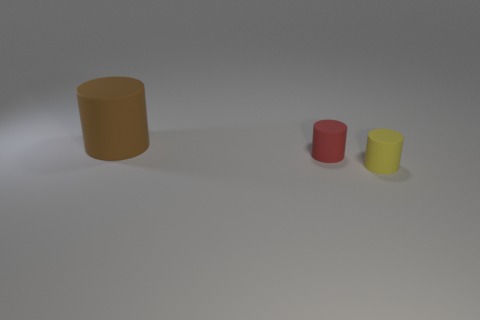Do the brown rubber cylinder and the yellow object have the same size?
Give a very brief answer. No. What number of balls are either tiny red matte things or large brown things?
Provide a succinct answer. 0. There is a tiny matte object behind the tiny cylinder that is to the right of the tiny red object; what color is it?
Keep it short and to the point. Red. Is the number of rubber objects that are in front of the yellow rubber thing less than the number of rubber objects on the left side of the red rubber cylinder?
Your answer should be compact. Yes. There is a brown thing; is it the same size as the red rubber cylinder that is on the left side of the yellow rubber cylinder?
Give a very brief answer. No. There is a rubber thing that is behind the tiny yellow cylinder and in front of the big object; what is its shape?
Your answer should be compact. Cylinder. There is a red object that is made of the same material as the yellow cylinder; what is its size?
Your answer should be very brief. Small. How many tiny rubber objects are right of the rubber object behind the red object?
Your answer should be compact. 2. Are the cylinder on the right side of the tiny red rubber object and the brown cylinder made of the same material?
Your answer should be very brief. Yes. What size is the red rubber thing behind the small object to the right of the red thing?
Offer a very short reply. Small. 